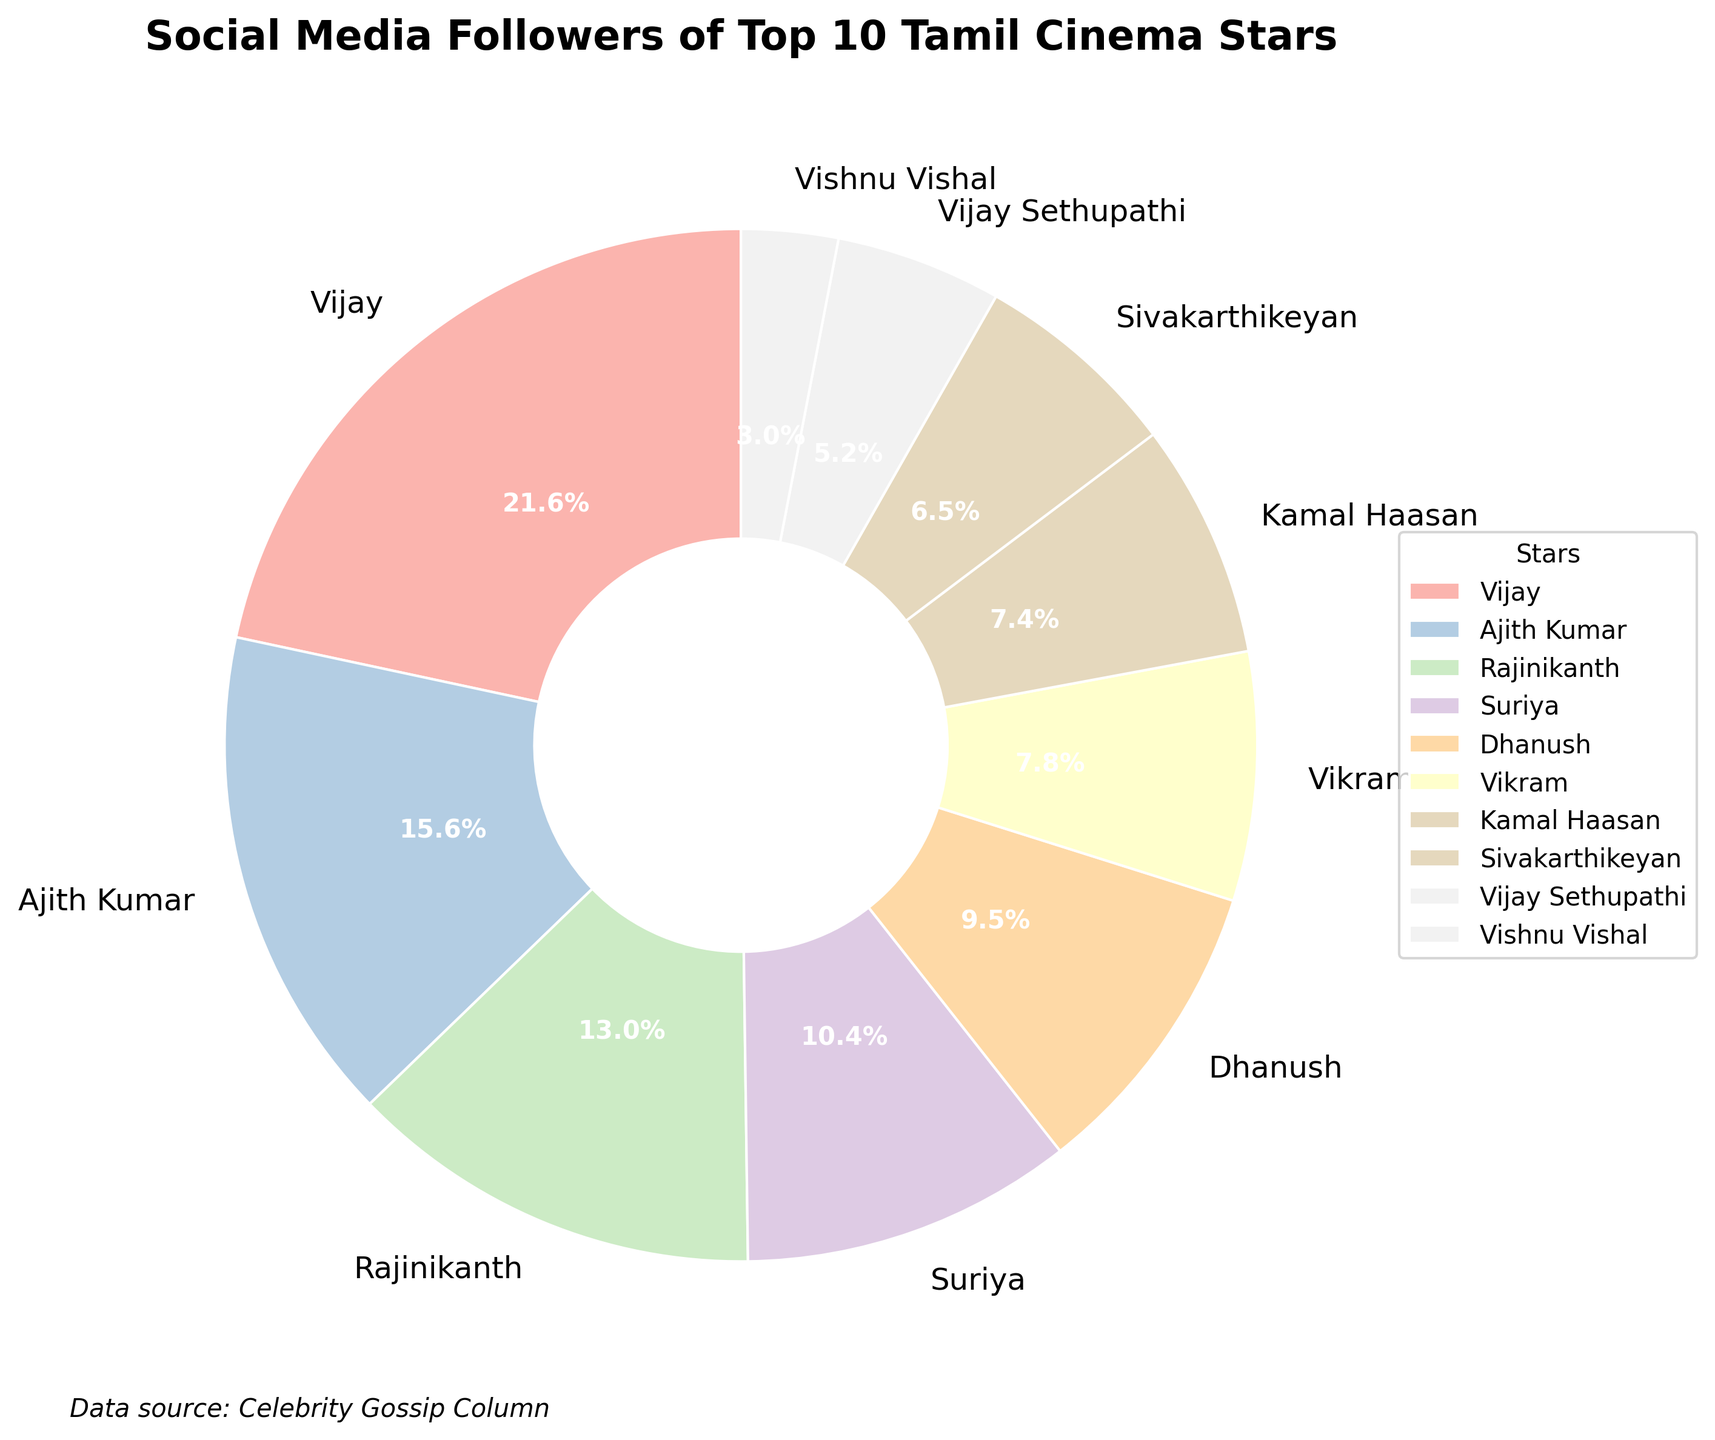Who has the highest number of social media followers? By looking at the pie chart, we can see the largest slice is associated with the label "Vijay." This indicates that Vijay has the highest number of social media followers.
Answer: Vijay How many stars have more than 15 million followers? From the pie chart, we can identify the stars with more than 15 million followers by looking at the relative size of the slices and their associated labels. The stars are Vijay, Ajith Kumar, and Rajinikanth.
Answer: 3 What percentage of the total social media followers does Vishnu Vishal have? Vishnu Vishal's slice has the percentage of 3.0% written inside it. This informs us that he has 3.0% of the total followers.
Answer: 3.0% Which two stars together make up nearly half of the total followers? By looking at the percentages in the pie chart, we can identify that Vijay (25.0%) and Ajith Kumar (18.0%) together accumulate to 43.0%, which is nearly half of the total.
Answer: Vijay and Ajith Kumar How do the social media followers of Vikram compare to those of Kamal Haasan? Looking at the slices for Vikram and Kamal Haasan, Vikram's slice is slightly larger than Kamal Haasan's, indicating that Vikram has more followers than Kamal Haasan.
Answer: Vikram has more followers What is the combined percentage of followers for Sivakarthikeyan and Vijay Sethupathi? Sivakarthikeyan's slice shows 7.5% and Vijay Sethupathi's slice shows 6.0%. Adding these gives a total of 13.5%.
Answer: 13.5% Whose slice is the smallest, and what percentage does it represent? By observing the smallest slice, we can see that it belongs to Vishnu Vishal, and the percentage inside is 3.0%.
Answer: Vishnu Vishal, 3.0% What is the difference in the number of followers between Vijay and Rajinikanth? Vijay has 25 million followers and Rajinikanth has 15 million followers. The difference between them is 25 million - 15 million = 10 million followers.
Answer: 10 million Is there any star with exactly 10% of the total followers? By visually scanning the labels and percentages on the pie chart, none of the slices show exactly 10%.
Answer: No Who among Dhanush and Suriya has more followers and by what percentage difference? Dhanush's slice shows 11.0% and Suriya's slice shows 12.0%. The difference is 12.0% - 11.0% = 1.0%, with Suriya having more followers.
Answer: Suriya by 1.0% 